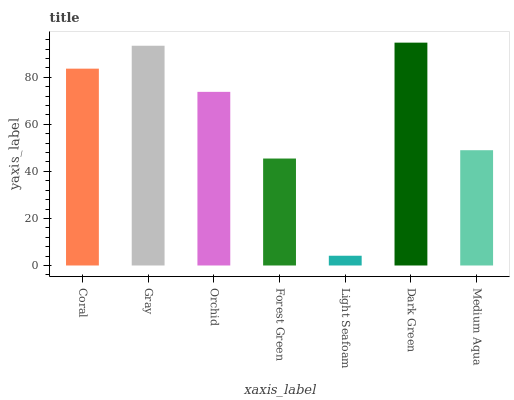Is Light Seafoam the minimum?
Answer yes or no. Yes. Is Dark Green the maximum?
Answer yes or no. Yes. Is Gray the minimum?
Answer yes or no. No. Is Gray the maximum?
Answer yes or no. No. Is Gray greater than Coral?
Answer yes or no. Yes. Is Coral less than Gray?
Answer yes or no. Yes. Is Coral greater than Gray?
Answer yes or no. No. Is Gray less than Coral?
Answer yes or no. No. Is Orchid the high median?
Answer yes or no. Yes. Is Orchid the low median?
Answer yes or no. Yes. Is Forest Green the high median?
Answer yes or no. No. Is Dark Green the low median?
Answer yes or no. No. 